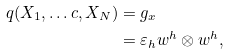Convert formula to latex. <formula><loc_0><loc_0><loc_500><loc_500>q ( X _ { 1 } , \dots c , X _ { N } ) & = g _ { x } \\ & = \varepsilon _ { h } w ^ { h } \otimes w ^ { h } ,</formula> 